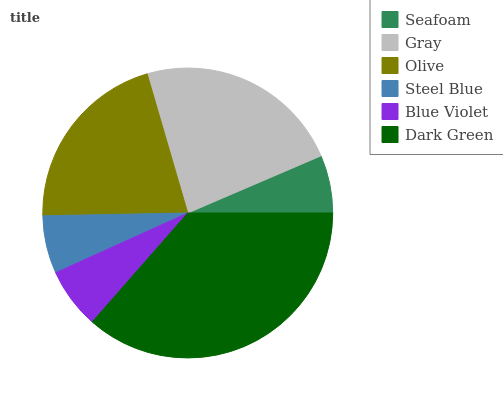Is Steel Blue the minimum?
Answer yes or no. Yes. Is Dark Green the maximum?
Answer yes or no. Yes. Is Gray the minimum?
Answer yes or no. No. Is Gray the maximum?
Answer yes or no. No. Is Gray greater than Seafoam?
Answer yes or no. Yes. Is Seafoam less than Gray?
Answer yes or no. Yes. Is Seafoam greater than Gray?
Answer yes or no. No. Is Gray less than Seafoam?
Answer yes or no. No. Is Olive the high median?
Answer yes or no. Yes. Is Blue Violet the low median?
Answer yes or no. Yes. Is Seafoam the high median?
Answer yes or no. No. Is Steel Blue the low median?
Answer yes or no. No. 